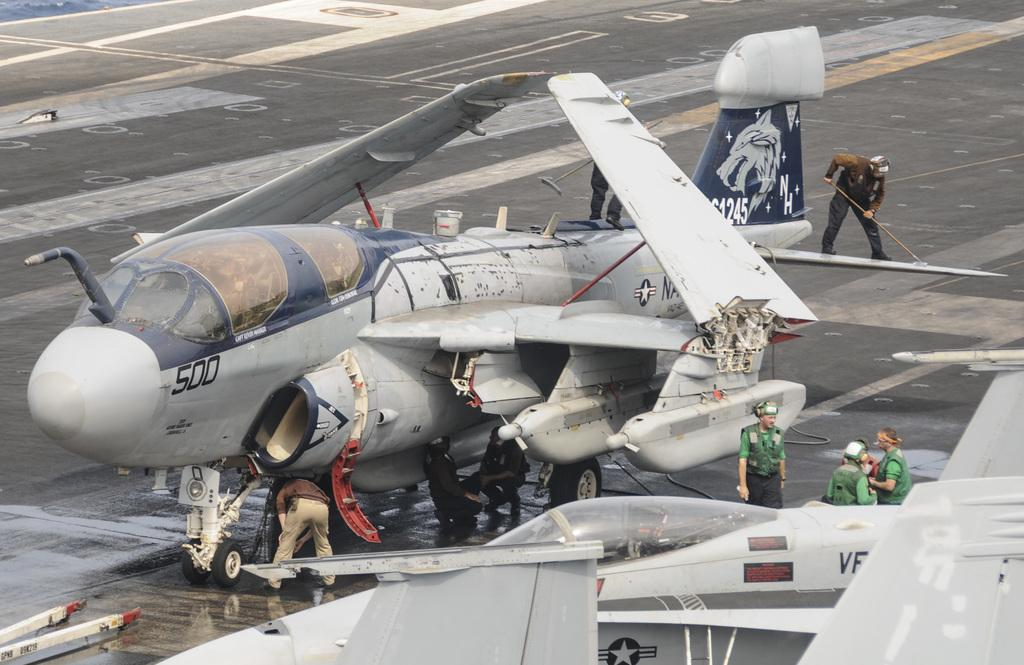Provide a one-sentence caption for the provided image. A military plane has the number 500 on its front section. 